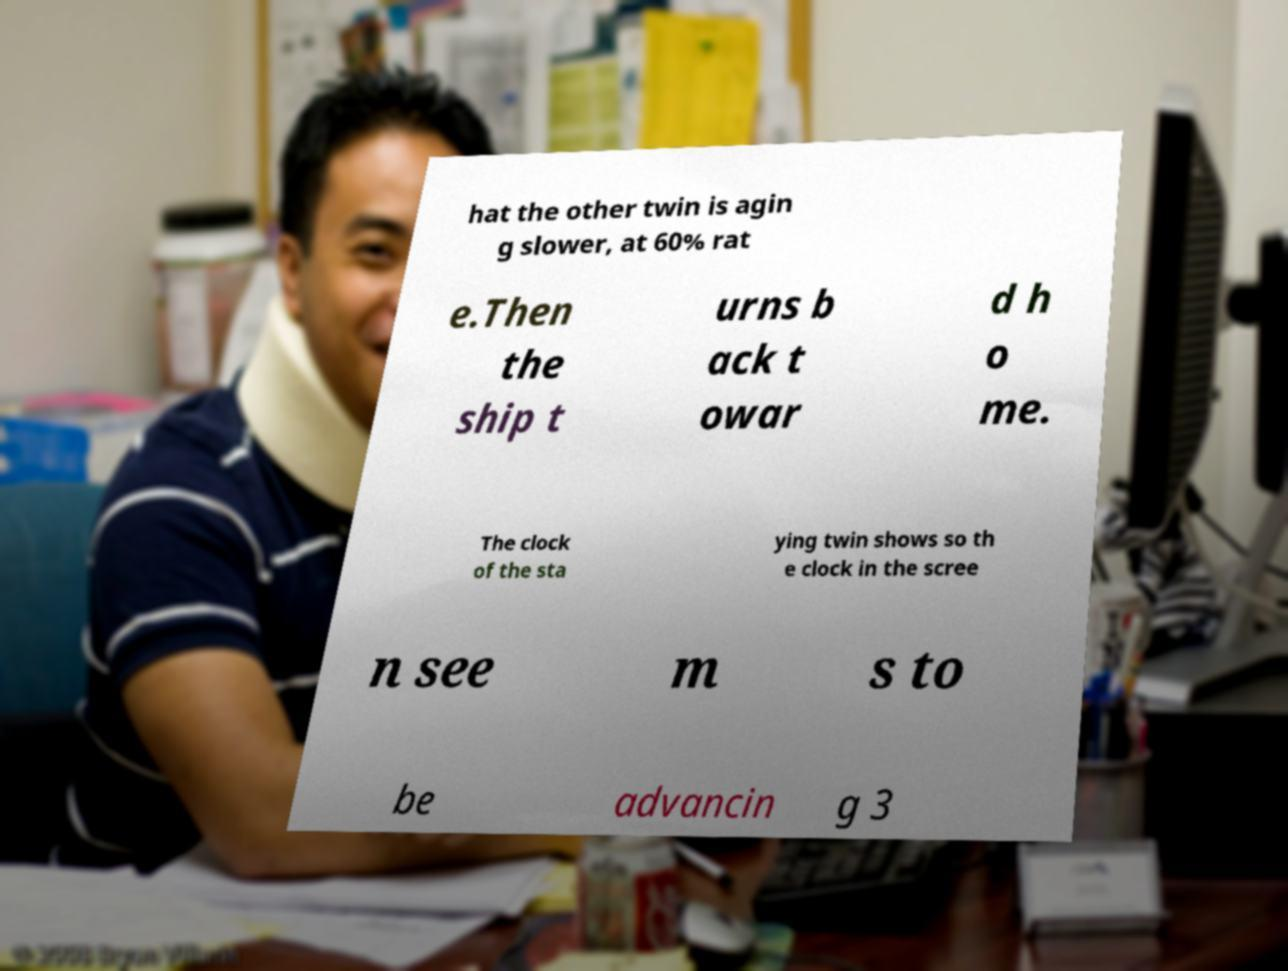I need the written content from this picture converted into text. Can you do that? hat the other twin is agin g slower, at 60% rat e.Then the ship t urns b ack t owar d h o me. The clock of the sta ying twin shows so th e clock in the scree n see m s to be advancin g 3 